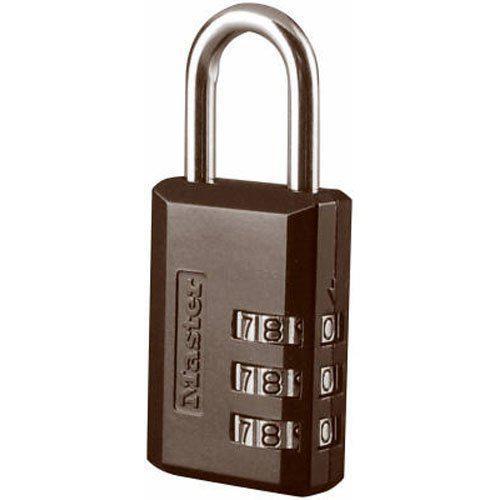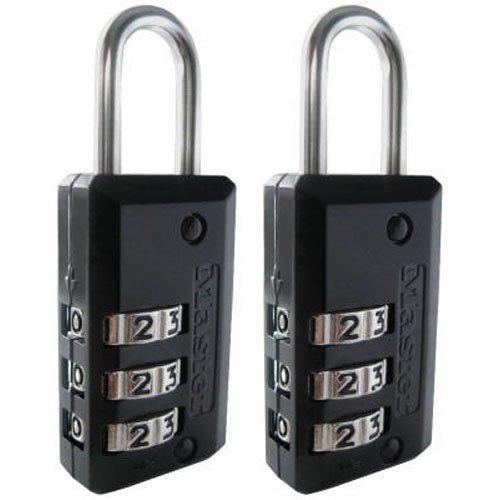The first image is the image on the left, the second image is the image on the right. Given the left and right images, does the statement "All locks are combination locks, with the number belts visible in the images." hold true? Answer yes or no. Yes. The first image is the image on the left, the second image is the image on the right. For the images shown, is this caption "There are no less than two black padlocks" true? Answer yes or no. Yes. 